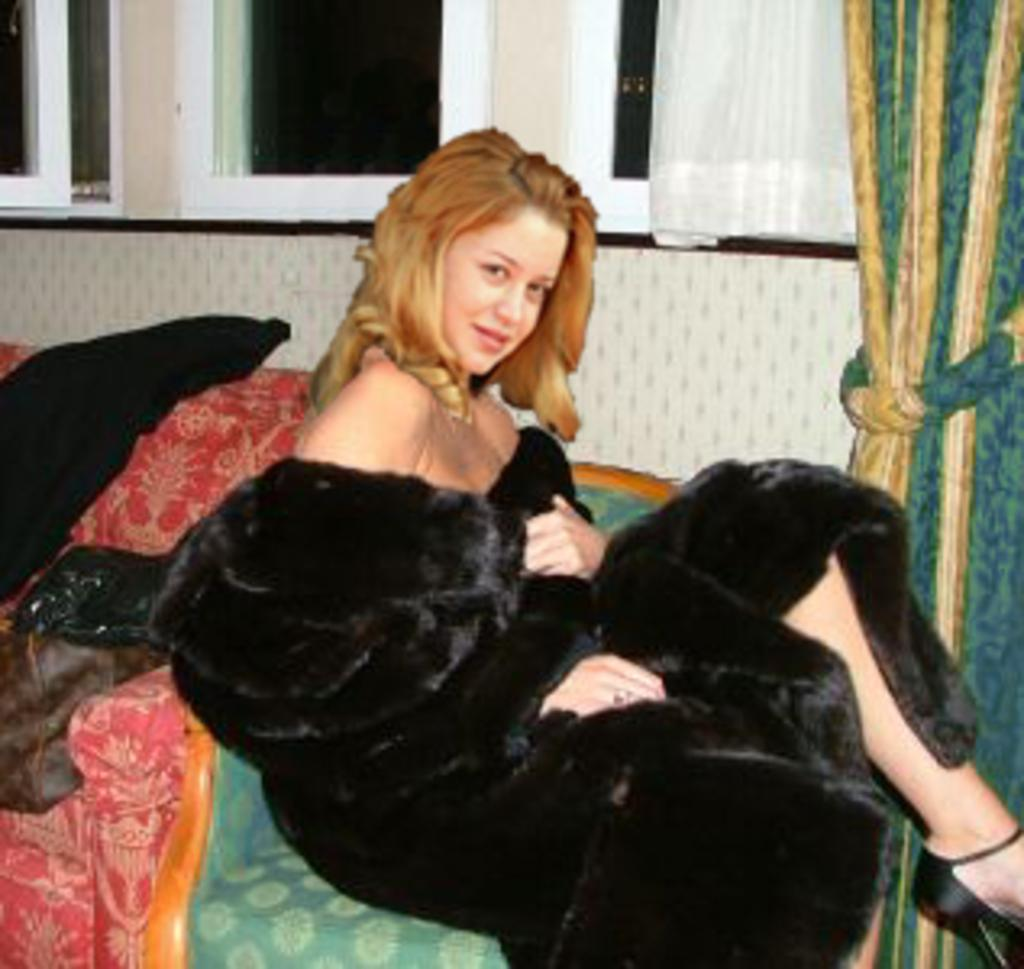What is the lady in the image doing? The lady is sitting on the couch in the image. What can be seen through the windows in the image? The windows in the image have curtains associated with them, but the view through the windows is not visible. What is the background of the image made up of? The background of the image includes a wall. What is placed on the couch with the lady? There are clothes on the couch. What type of cave can be seen in the background of the image? There is no cave present in the image; it features a lady sitting on a couch with clothes on it, surrounded by windows, curtains, and a wall. 